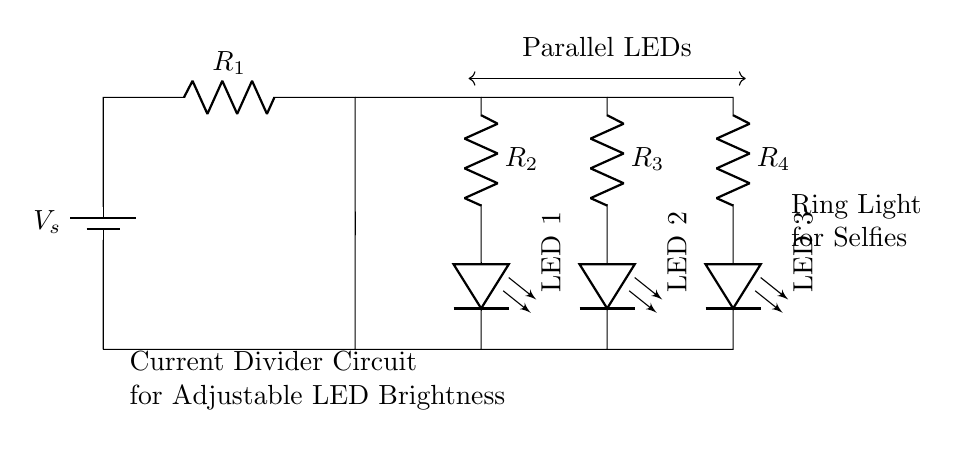What is the main function of this circuit? The main function of the circuit is to adjust LED brightness. The parallel configuration allows for varying currents through each LED, thus controlling their brightness levels.
Answer: adjusting LED brightness How many resistors are in this circuit? The circuit contains four resistors (R1, R2, R3, R4) shown in the diagram. Each resistor is connected in parallel with an LED.
Answer: four What type of circuit is this? This is a parallel circuit, as indicated by the multiple branches connecting the LEDs and resistors. This configuration allows the same voltage across all components while allowing different current values.
Answer: parallel circuit If R2 has a resistance of 100 ohms, what current flows through LED 1 if the voltage is 5 volts? Using Ohm's Law (current equals voltage divided by resistance), the current through LED 1 would be 5 volts divided by 100 ohms, resulting in 0.05 amperes.
Answer: 0.05 amperes Which LED is connected to resistor R3? LED 2 is connected to resistor R3, as shown by the direct line connecting the resistor to that specific LED in the diagram.
Answer: LED 2 What happens if one LED is removed from the circuit? If one LED is removed, the total current through the remaining parallel components will change, but the other LEDs will continue to operate independently. This is a key feature of parallel circuits.
Answer: the remaining LEDs continue to function 